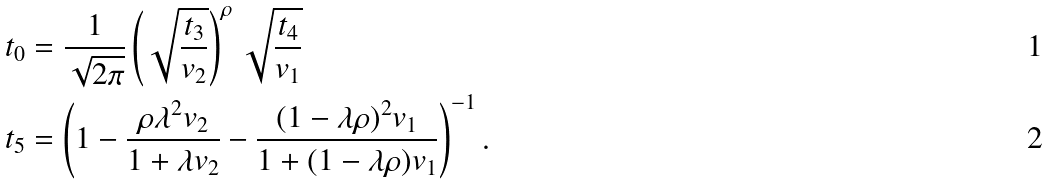Convert formula to latex. <formula><loc_0><loc_0><loc_500><loc_500>t _ { 0 } & = \frac { 1 } { \sqrt { 2 \pi } } \left ( \sqrt { \frac { t _ { 3 } } { v _ { 2 } } } \right ) ^ { \rho } \sqrt { \frac { t _ { 4 } } { v _ { 1 } } } \\ t _ { 5 } & = \left ( 1 - \frac { \rho \lambda ^ { 2 } v _ { 2 } } { 1 + \lambda v _ { 2 } } - \frac { ( 1 - \lambda \rho ) ^ { 2 } v _ { 1 } } { 1 + ( 1 - \lambda \rho ) v _ { 1 } } \right ) ^ { - 1 } .</formula> 